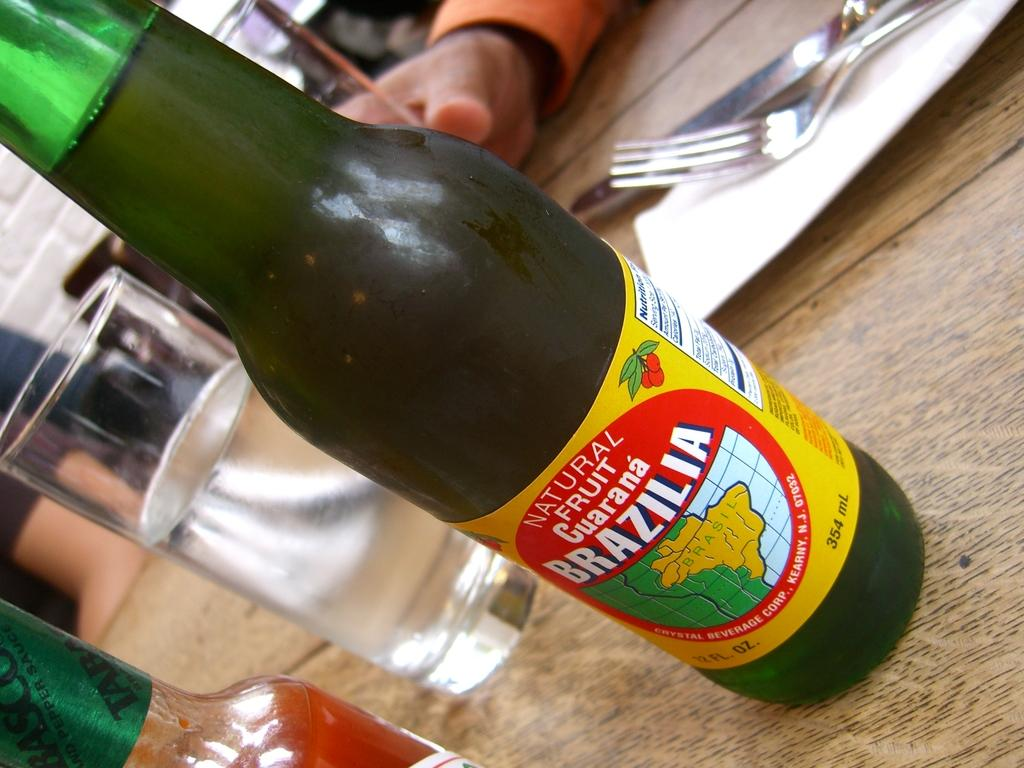Provide a one-sentence caption for the provided image. A full bottle containing natural fruit guarana called Brazilia. 